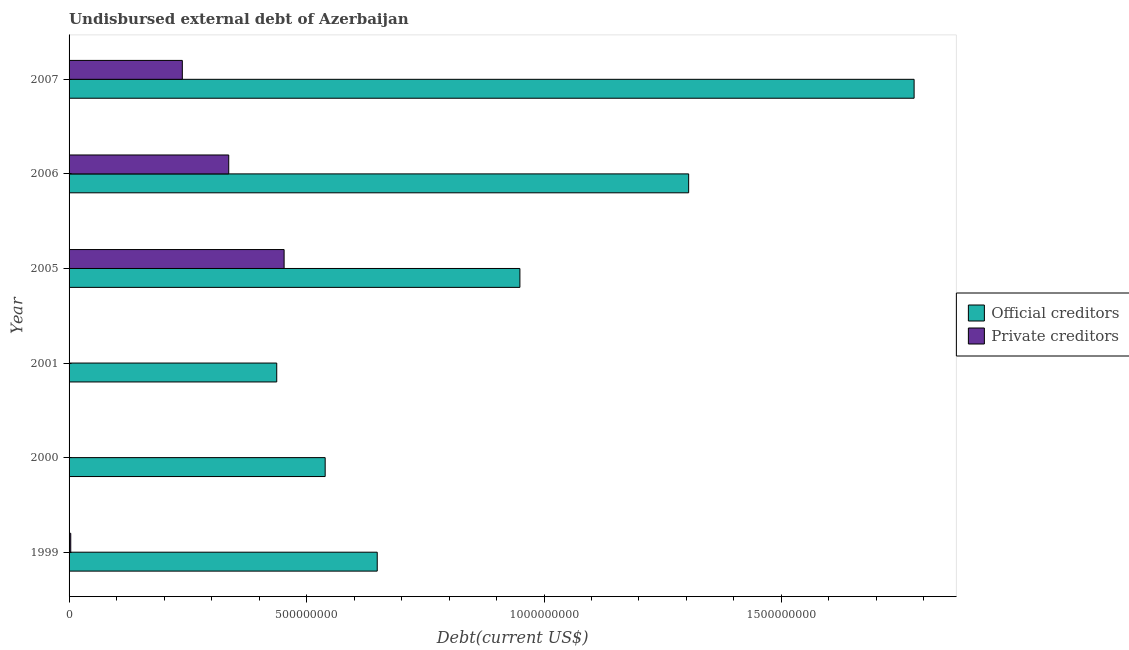How many different coloured bars are there?
Your answer should be very brief. 2. Are the number of bars on each tick of the Y-axis equal?
Provide a short and direct response. Yes. What is the label of the 4th group of bars from the top?
Give a very brief answer. 2001. What is the undisbursed external debt of private creditors in 2000?
Make the answer very short. 5.81e+05. Across all years, what is the maximum undisbursed external debt of official creditors?
Your answer should be compact. 1.78e+09. Across all years, what is the minimum undisbursed external debt of private creditors?
Provide a short and direct response. 4.40e+04. In which year was the undisbursed external debt of private creditors minimum?
Ensure brevity in your answer.  2001. What is the total undisbursed external debt of private creditors in the graph?
Offer a terse response. 1.03e+09. What is the difference between the undisbursed external debt of official creditors in 2000 and that in 2001?
Give a very brief answer. 1.02e+08. What is the difference between the undisbursed external debt of private creditors in 2005 and the undisbursed external debt of official creditors in 2006?
Offer a terse response. -8.52e+08. What is the average undisbursed external debt of official creditors per year?
Provide a succinct answer. 9.43e+08. In the year 2000, what is the difference between the undisbursed external debt of official creditors and undisbursed external debt of private creditors?
Keep it short and to the point. 5.39e+08. What is the ratio of the undisbursed external debt of private creditors in 2005 to that in 2006?
Offer a terse response. 1.35. Is the undisbursed external debt of official creditors in 1999 less than that in 2001?
Offer a very short reply. No. What is the difference between the highest and the second highest undisbursed external debt of private creditors?
Your response must be concise. 1.17e+08. What is the difference between the highest and the lowest undisbursed external debt of private creditors?
Give a very brief answer. 4.53e+08. Is the sum of the undisbursed external debt of official creditors in 2000 and 2005 greater than the maximum undisbursed external debt of private creditors across all years?
Provide a succinct answer. Yes. What does the 1st bar from the top in 2007 represents?
Offer a terse response. Private creditors. What does the 2nd bar from the bottom in 2006 represents?
Keep it short and to the point. Private creditors. Are all the bars in the graph horizontal?
Ensure brevity in your answer.  Yes. What is the difference between two consecutive major ticks on the X-axis?
Offer a very short reply. 5.00e+08. Are the values on the major ticks of X-axis written in scientific E-notation?
Your response must be concise. No. Where does the legend appear in the graph?
Keep it short and to the point. Center right. How many legend labels are there?
Provide a succinct answer. 2. What is the title of the graph?
Offer a very short reply. Undisbursed external debt of Azerbaijan. Does "Urban" appear as one of the legend labels in the graph?
Offer a very short reply. No. What is the label or title of the X-axis?
Your answer should be compact. Debt(current US$). What is the label or title of the Y-axis?
Your response must be concise. Year. What is the Debt(current US$) of Official creditors in 1999?
Ensure brevity in your answer.  6.49e+08. What is the Debt(current US$) in Private creditors in 1999?
Offer a terse response. 3.53e+06. What is the Debt(current US$) of Official creditors in 2000?
Your response must be concise. 5.39e+08. What is the Debt(current US$) of Private creditors in 2000?
Keep it short and to the point. 5.81e+05. What is the Debt(current US$) of Official creditors in 2001?
Offer a terse response. 4.37e+08. What is the Debt(current US$) of Private creditors in 2001?
Provide a short and direct response. 4.40e+04. What is the Debt(current US$) in Official creditors in 2005?
Make the answer very short. 9.49e+08. What is the Debt(current US$) in Private creditors in 2005?
Keep it short and to the point. 4.53e+08. What is the Debt(current US$) in Official creditors in 2006?
Offer a very short reply. 1.30e+09. What is the Debt(current US$) of Private creditors in 2006?
Provide a succinct answer. 3.36e+08. What is the Debt(current US$) of Official creditors in 2007?
Make the answer very short. 1.78e+09. What is the Debt(current US$) in Private creditors in 2007?
Your answer should be compact. 2.38e+08. Across all years, what is the maximum Debt(current US$) in Official creditors?
Your answer should be very brief. 1.78e+09. Across all years, what is the maximum Debt(current US$) of Private creditors?
Your response must be concise. 4.53e+08. Across all years, what is the minimum Debt(current US$) in Official creditors?
Provide a succinct answer. 4.37e+08. Across all years, what is the minimum Debt(current US$) of Private creditors?
Keep it short and to the point. 4.40e+04. What is the total Debt(current US$) of Official creditors in the graph?
Your answer should be very brief. 5.66e+09. What is the total Debt(current US$) of Private creditors in the graph?
Make the answer very short. 1.03e+09. What is the difference between the Debt(current US$) of Official creditors in 1999 and that in 2000?
Provide a succinct answer. 1.10e+08. What is the difference between the Debt(current US$) of Private creditors in 1999 and that in 2000?
Provide a succinct answer. 2.95e+06. What is the difference between the Debt(current US$) in Official creditors in 1999 and that in 2001?
Your answer should be very brief. 2.12e+08. What is the difference between the Debt(current US$) in Private creditors in 1999 and that in 2001?
Your answer should be very brief. 3.49e+06. What is the difference between the Debt(current US$) in Official creditors in 1999 and that in 2005?
Offer a terse response. -3.00e+08. What is the difference between the Debt(current US$) of Private creditors in 1999 and that in 2005?
Offer a very short reply. -4.49e+08. What is the difference between the Debt(current US$) in Official creditors in 1999 and that in 2006?
Offer a very short reply. -6.56e+08. What is the difference between the Debt(current US$) of Private creditors in 1999 and that in 2006?
Offer a terse response. -3.33e+08. What is the difference between the Debt(current US$) of Official creditors in 1999 and that in 2007?
Provide a succinct answer. -1.13e+09. What is the difference between the Debt(current US$) of Private creditors in 1999 and that in 2007?
Offer a terse response. -2.35e+08. What is the difference between the Debt(current US$) in Official creditors in 2000 and that in 2001?
Offer a terse response. 1.02e+08. What is the difference between the Debt(current US$) of Private creditors in 2000 and that in 2001?
Your answer should be compact. 5.37e+05. What is the difference between the Debt(current US$) of Official creditors in 2000 and that in 2005?
Ensure brevity in your answer.  -4.10e+08. What is the difference between the Debt(current US$) of Private creditors in 2000 and that in 2005?
Provide a succinct answer. -4.52e+08. What is the difference between the Debt(current US$) in Official creditors in 2000 and that in 2006?
Offer a very short reply. -7.65e+08. What is the difference between the Debt(current US$) of Private creditors in 2000 and that in 2006?
Provide a succinct answer. -3.36e+08. What is the difference between the Debt(current US$) of Official creditors in 2000 and that in 2007?
Keep it short and to the point. -1.24e+09. What is the difference between the Debt(current US$) in Private creditors in 2000 and that in 2007?
Offer a very short reply. -2.38e+08. What is the difference between the Debt(current US$) of Official creditors in 2001 and that in 2005?
Offer a terse response. -5.12e+08. What is the difference between the Debt(current US$) in Private creditors in 2001 and that in 2005?
Offer a very short reply. -4.53e+08. What is the difference between the Debt(current US$) in Official creditors in 2001 and that in 2006?
Provide a succinct answer. -8.67e+08. What is the difference between the Debt(current US$) of Private creditors in 2001 and that in 2006?
Give a very brief answer. -3.36e+08. What is the difference between the Debt(current US$) in Official creditors in 2001 and that in 2007?
Your answer should be compact. -1.34e+09. What is the difference between the Debt(current US$) in Private creditors in 2001 and that in 2007?
Ensure brevity in your answer.  -2.38e+08. What is the difference between the Debt(current US$) of Official creditors in 2005 and that in 2006?
Ensure brevity in your answer.  -3.55e+08. What is the difference between the Debt(current US$) of Private creditors in 2005 and that in 2006?
Your answer should be very brief. 1.17e+08. What is the difference between the Debt(current US$) in Official creditors in 2005 and that in 2007?
Your answer should be compact. -8.30e+08. What is the difference between the Debt(current US$) of Private creditors in 2005 and that in 2007?
Offer a terse response. 2.14e+08. What is the difference between the Debt(current US$) in Official creditors in 2006 and that in 2007?
Offer a very short reply. -4.75e+08. What is the difference between the Debt(current US$) in Private creditors in 2006 and that in 2007?
Your answer should be very brief. 9.77e+07. What is the difference between the Debt(current US$) of Official creditors in 1999 and the Debt(current US$) of Private creditors in 2000?
Ensure brevity in your answer.  6.48e+08. What is the difference between the Debt(current US$) of Official creditors in 1999 and the Debt(current US$) of Private creditors in 2001?
Provide a succinct answer. 6.49e+08. What is the difference between the Debt(current US$) of Official creditors in 1999 and the Debt(current US$) of Private creditors in 2005?
Provide a short and direct response. 1.96e+08. What is the difference between the Debt(current US$) of Official creditors in 1999 and the Debt(current US$) of Private creditors in 2006?
Provide a succinct answer. 3.13e+08. What is the difference between the Debt(current US$) in Official creditors in 1999 and the Debt(current US$) in Private creditors in 2007?
Your answer should be compact. 4.10e+08. What is the difference between the Debt(current US$) of Official creditors in 2000 and the Debt(current US$) of Private creditors in 2001?
Give a very brief answer. 5.39e+08. What is the difference between the Debt(current US$) of Official creditors in 2000 and the Debt(current US$) of Private creditors in 2005?
Your response must be concise. 8.64e+07. What is the difference between the Debt(current US$) in Official creditors in 2000 and the Debt(current US$) in Private creditors in 2006?
Give a very brief answer. 2.03e+08. What is the difference between the Debt(current US$) of Official creditors in 2000 and the Debt(current US$) of Private creditors in 2007?
Ensure brevity in your answer.  3.01e+08. What is the difference between the Debt(current US$) in Official creditors in 2001 and the Debt(current US$) in Private creditors in 2005?
Your answer should be compact. -1.56e+07. What is the difference between the Debt(current US$) of Official creditors in 2001 and the Debt(current US$) of Private creditors in 2006?
Provide a short and direct response. 1.01e+08. What is the difference between the Debt(current US$) in Official creditors in 2001 and the Debt(current US$) in Private creditors in 2007?
Provide a succinct answer. 1.99e+08. What is the difference between the Debt(current US$) in Official creditors in 2005 and the Debt(current US$) in Private creditors in 2006?
Keep it short and to the point. 6.13e+08. What is the difference between the Debt(current US$) of Official creditors in 2005 and the Debt(current US$) of Private creditors in 2007?
Provide a succinct answer. 7.11e+08. What is the difference between the Debt(current US$) of Official creditors in 2006 and the Debt(current US$) of Private creditors in 2007?
Give a very brief answer. 1.07e+09. What is the average Debt(current US$) of Official creditors per year?
Your answer should be very brief. 9.43e+08. What is the average Debt(current US$) in Private creditors per year?
Make the answer very short. 1.72e+08. In the year 1999, what is the difference between the Debt(current US$) in Official creditors and Debt(current US$) in Private creditors?
Offer a terse response. 6.45e+08. In the year 2000, what is the difference between the Debt(current US$) in Official creditors and Debt(current US$) in Private creditors?
Ensure brevity in your answer.  5.39e+08. In the year 2001, what is the difference between the Debt(current US$) in Official creditors and Debt(current US$) in Private creditors?
Your answer should be very brief. 4.37e+08. In the year 2005, what is the difference between the Debt(current US$) in Official creditors and Debt(current US$) in Private creditors?
Make the answer very short. 4.96e+08. In the year 2006, what is the difference between the Debt(current US$) of Official creditors and Debt(current US$) of Private creditors?
Give a very brief answer. 9.68e+08. In the year 2007, what is the difference between the Debt(current US$) in Official creditors and Debt(current US$) in Private creditors?
Ensure brevity in your answer.  1.54e+09. What is the ratio of the Debt(current US$) of Official creditors in 1999 to that in 2000?
Offer a terse response. 1.2. What is the ratio of the Debt(current US$) in Private creditors in 1999 to that in 2000?
Your answer should be compact. 6.08. What is the ratio of the Debt(current US$) in Official creditors in 1999 to that in 2001?
Provide a succinct answer. 1.48. What is the ratio of the Debt(current US$) of Private creditors in 1999 to that in 2001?
Your answer should be compact. 80.27. What is the ratio of the Debt(current US$) in Official creditors in 1999 to that in 2005?
Give a very brief answer. 0.68. What is the ratio of the Debt(current US$) in Private creditors in 1999 to that in 2005?
Your answer should be very brief. 0.01. What is the ratio of the Debt(current US$) in Official creditors in 1999 to that in 2006?
Provide a succinct answer. 0.5. What is the ratio of the Debt(current US$) of Private creditors in 1999 to that in 2006?
Provide a short and direct response. 0.01. What is the ratio of the Debt(current US$) in Official creditors in 1999 to that in 2007?
Provide a short and direct response. 0.36. What is the ratio of the Debt(current US$) in Private creditors in 1999 to that in 2007?
Give a very brief answer. 0.01. What is the ratio of the Debt(current US$) of Official creditors in 2000 to that in 2001?
Make the answer very short. 1.23. What is the ratio of the Debt(current US$) in Private creditors in 2000 to that in 2001?
Keep it short and to the point. 13.2. What is the ratio of the Debt(current US$) of Official creditors in 2000 to that in 2005?
Ensure brevity in your answer.  0.57. What is the ratio of the Debt(current US$) of Private creditors in 2000 to that in 2005?
Your answer should be compact. 0. What is the ratio of the Debt(current US$) in Official creditors in 2000 to that in 2006?
Keep it short and to the point. 0.41. What is the ratio of the Debt(current US$) in Private creditors in 2000 to that in 2006?
Keep it short and to the point. 0. What is the ratio of the Debt(current US$) of Official creditors in 2000 to that in 2007?
Make the answer very short. 0.3. What is the ratio of the Debt(current US$) in Private creditors in 2000 to that in 2007?
Give a very brief answer. 0. What is the ratio of the Debt(current US$) of Official creditors in 2001 to that in 2005?
Your response must be concise. 0.46. What is the ratio of the Debt(current US$) in Official creditors in 2001 to that in 2006?
Your response must be concise. 0.34. What is the ratio of the Debt(current US$) in Private creditors in 2001 to that in 2006?
Ensure brevity in your answer.  0. What is the ratio of the Debt(current US$) of Official creditors in 2001 to that in 2007?
Your answer should be compact. 0.25. What is the ratio of the Debt(current US$) in Private creditors in 2001 to that in 2007?
Your answer should be compact. 0. What is the ratio of the Debt(current US$) in Official creditors in 2005 to that in 2006?
Offer a very short reply. 0.73. What is the ratio of the Debt(current US$) of Private creditors in 2005 to that in 2006?
Offer a very short reply. 1.35. What is the ratio of the Debt(current US$) in Official creditors in 2005 to that in 2007?
Keep it short and to the point. 0.53. What is the ratio of the Debt(current US$) of Private creditors in 2005 to that in 2007?
Offer a very short reply. 1.9. What is the ratio of the Debt(current US$) in Official creditors in 2006 to that in 2007?
Provide a succinct answer. 0.73. What is the ratio of the Debt(current US$) in Private creditors in 2006 to that in 2007?
Offer a very short reply. 1.41. What is the difference between the highest and the second highest Debt(current US$) in Official creditors?
Give a very brief answer. 4.75e+08. What is the difference between the highest and the second highest Debt(current US$) of Private creditors?
Provide a short and direct response. 1.17e+08. What is the difference between the highest and the lowest Debt(current US$) in Official creditors?
Your answer should be very brief. 1.34e+09. What is the difference between the highest and the lowest Debt(current US$) of Private creditors?
Keep it short and to the point. 4.53e+08. 